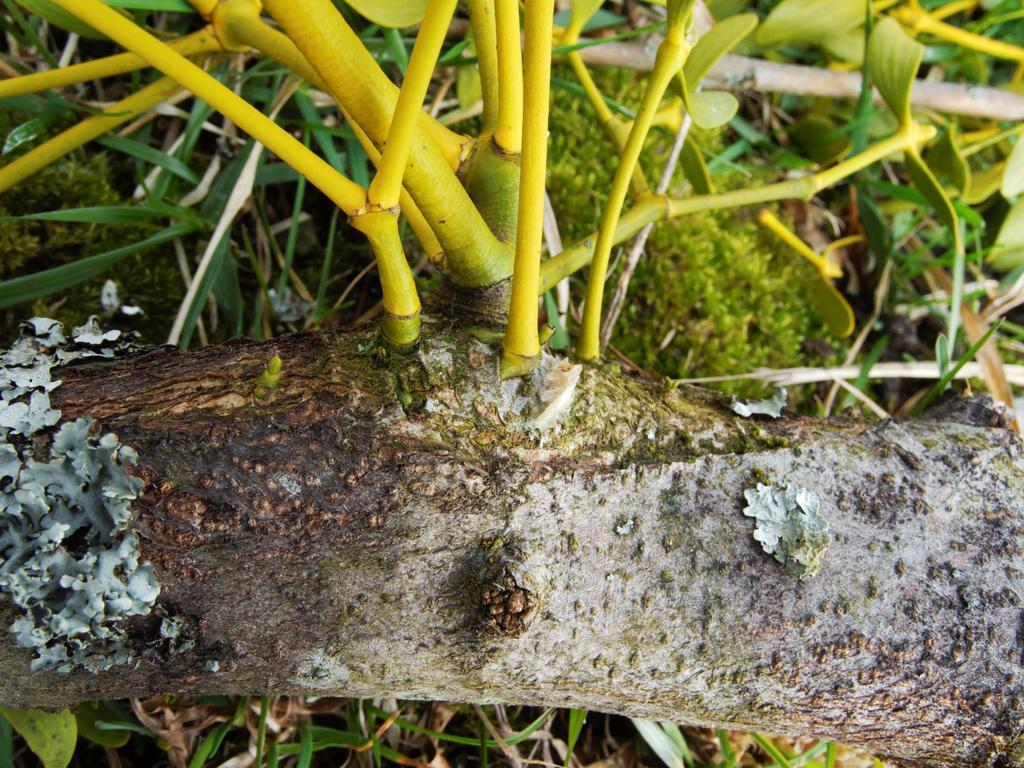How would you summarize this image in a sentence or two? In this image we can see one tree with branches, some plants, some bushes, some grass on the surface. 